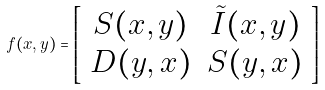<formula> <loc_0><loc_0><loc_500><loc_500>f ( x , y ) = \left [ \begin{array} { c c } S ( x , y ) & \tilde { I } ( x , y ) \\ D ( y , x ) & S ( y , x ) \\ \end{array} \right ]</formula> 